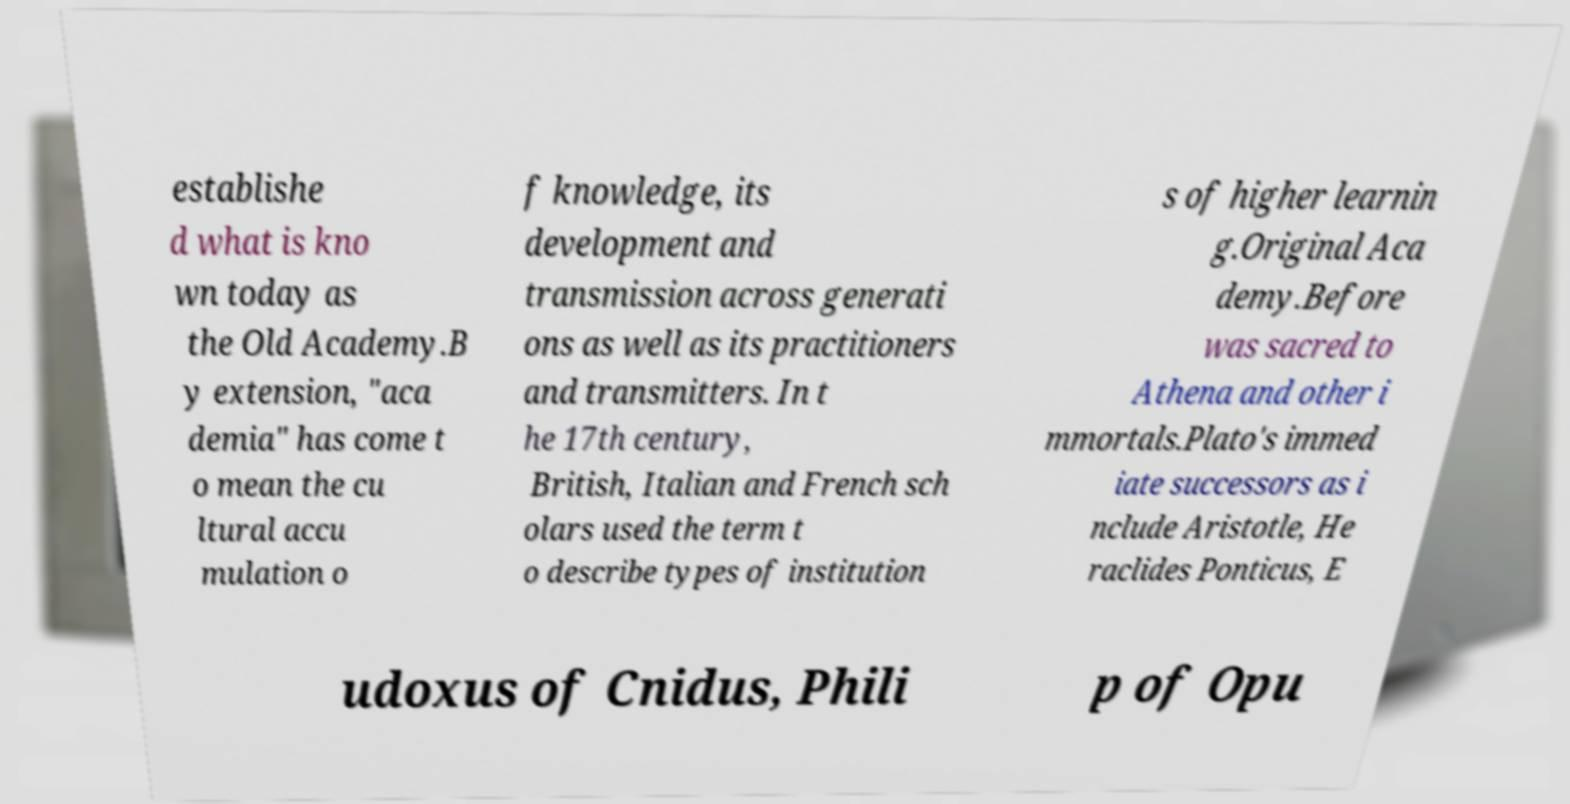I need the written content from this picture converted into text. Can you do that? establishe d what is kno wn today as the Old Academy.B y extension, "aca demia" has come t o mean the cu ltural accu mulation o f knowledge, its development and transmission across generati ons as well as its practitioners and transmitters. In t he 17th century, British, Italian and French sch olars used the term t o describe types of institution s of higher learnin g.Original Aca demy.Before was sacred to Athena and other i mmortals.Plato's immed iate successors as i nclude Aristotle, He raclides Ponticus, E udoxus of Cnidus, Phili p of Opu 